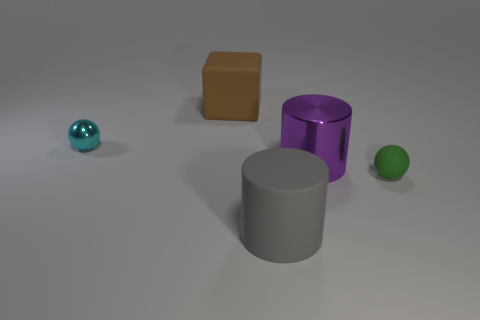How would the presence of light affect the appearance of these objects? The appearance of these objects would change significantly with different lighting. Highlights and shadows would become more pronounced, altering the perceived depth and contours. The colors might appear more vibrant or more subdued, depending on the intensity and angle of the light source. 